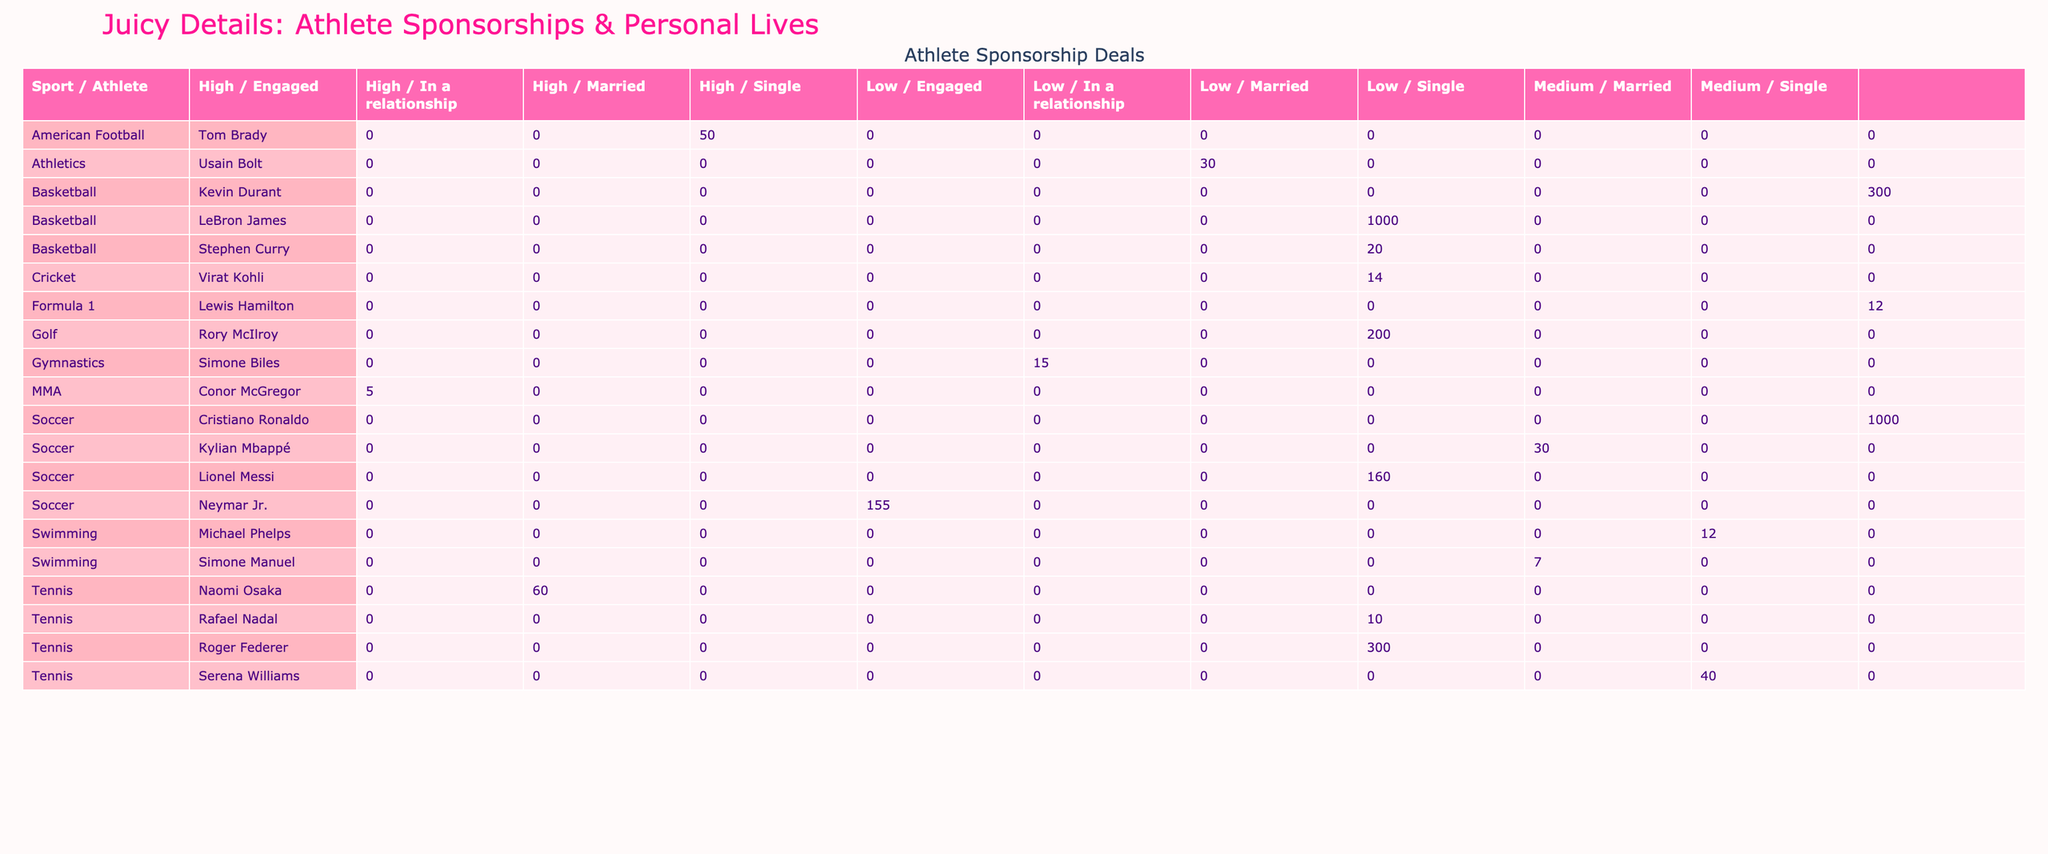What is the total endorsement value of soccer athletes? To find the total endorsement value for soccer athletes, I need to sum the deal values for all athletes in the soccer category. The athletes and their deal values are: Cristiano Ronaldo ($1000M), Lionel Messi ($160M), Neymar Jr. ($155M), and Kylian Mbappé ($30M). Adding these gives $1000 + $160 + $155 + $30 = $1345M.
Answer: 1345M Which sport has the highest total deal value? To find the sport with the highest total deal value, I’ll sum the deal values for each sport and compare them. For basketball: LeBron James ($1000M) + Kevin Durant ($300M) + Stephen Curry ($20M) = $1320M. For soccer: Cristiano Ronaldo ($1000M) + Lionel Messi ($160M) + Neymar Jr. ($155M) + Kylian Mbappé ($30M) = $1345M. For tennis: Roger Federer ($300M) + Serena Williams ($40M) + Naomi Osaka ($60M) + Rafael Nadal ($10M) = $410M. The highest total is in soccer, with $1345M.
Answer: Soccer Is there an athlete with a lifetime deal value of more than $500M? The only athletes with lifetime deals are LeBron James (1000M), Cristiano Ronaldo (1000M), Lionel Messi (160M), and Usain Bolt (30M). Both LeBron James and Cristiano Ronaldo have a deal value of 1000M, which is above 500M. Therefore, the answer is yes.
Answer: Yes Which athlete involved in a scandal has the highest deal value? I need to look at the athletes who are involved in scandals: Neymar Jr. (High, $155M), Tom Brady (High, $50M), and Conor McGregor (High, $5M). The highest deal value among them is Neymar Jr. with $155M.
Answer: Neymar Jr How many athletes are married and have a deal value over $200M? From the table, the married athletes and their deal values are: LeBron James ($1000M), Lionel Messi ($160M), Roger Federer ($300M), Serena Williams ($40M), Tom Brady ($50M), Rafael Nadal ($10M), Rory McIlroy ($200M). The only married athlete with a deal value over $200M is LeBron James ($1000M) and Roger Federer ($300M). Therefore, there are 2 such athletes.
Answer: 2 What is the average deal value of athletes in gymnastics? There is only one athlete in gymnastics, Simone Biles, with a deal value of $15M. If there’s only one value, the average is simply $15M, as there isn’t other data to compute against.
Answer: 15M Which athlete with low scandal involvement has the lowest deal value? I will filter the athletes involved in low scandals and look for the one with the lowest deal value. The athletes are: Roger Federer ($300M), Serena Williams ($40M), Usain Bolt ($30M), Kylian Mbappé ($30M), Lionel Messi ($160M), and Virat Kohli ($14M). Among these, Usain Bolt and Kylian Mbappé both have $30M, making it the lowest.
Answer: Usain Bolt/Kylian Mbappé How many athletes are single with endorsement deals under $50M? The single athletes with deals under $50M are Conor McGregor ($5M) and Usain Bolt ($30M). Therefore, there are 2 athletes fitting this description.
Answer: 2 Which athlete has the highest social media following among those with high scandal involvement? Among these athletes involved in high scandal situations, Neymar Jr. has 200M followers, Tom Brady has 12M, and Conor McGregor has 45M followers. The highest count is 200M by Neymar Jr.
Answer: Neymar Jr 